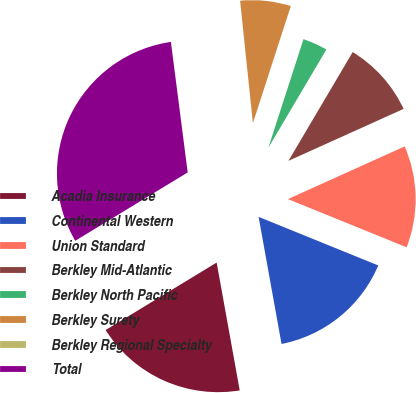Convert chart to OTSL. <chart><loc_0><loc_0><loc_500><loc_500><pie_chart><fcel>Acadia Insurance<fcel>Continental Western<fcel>Union Standard<fcel>Berkley Mid-Atlantic<fcel>Berkley North Pacific<fcel>Berkley Surety<fcel>Berkley Regional Specialty<fcel>Total<nl><fcel>19.15%<fcel>16.02%<fcel>12.89%<fcel>9.76%<fcel>3.51%<fcel>6.64%<fcel>0.38%<fcel>31.66%<nl></chart> 